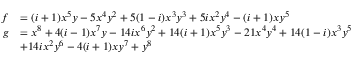<formula> <loc_0><loc_0><loc_500><loc_500>\begin{array} { r l } { f } & { = ( i + 1 ) x ^ { 5 } y - 5 x ^ { 4 } y ^ { 2 } + 5 ( 1 - i ) x ^ { 3 } y ^ { 3 } + 5 i x ^ { 2 } y ^ { 4 } - ( i + 1 ) x y ^ { 5 } } \\ { g } & { = x ^ { 8 } + 4 ( i - 1 ) x ^ { 7 } y - 1 4 i x ^ { 6 } y ^ { 2 } + 1 4 ( i + 1 ) x ^ { 5 } y ^ { 3 } - 2 1 x ^ { 4 } y ^ { 4 } + 1 4 ( 1 - i ) x ^ { 3 } y ^ { 5 } } \\ & { + 1 4 i x ^ { 2 } y ^ { 6 } - 4 ( i + 1 ) x y ^ { 7 } + y ^ { 8 } } \end{array}</formula> 